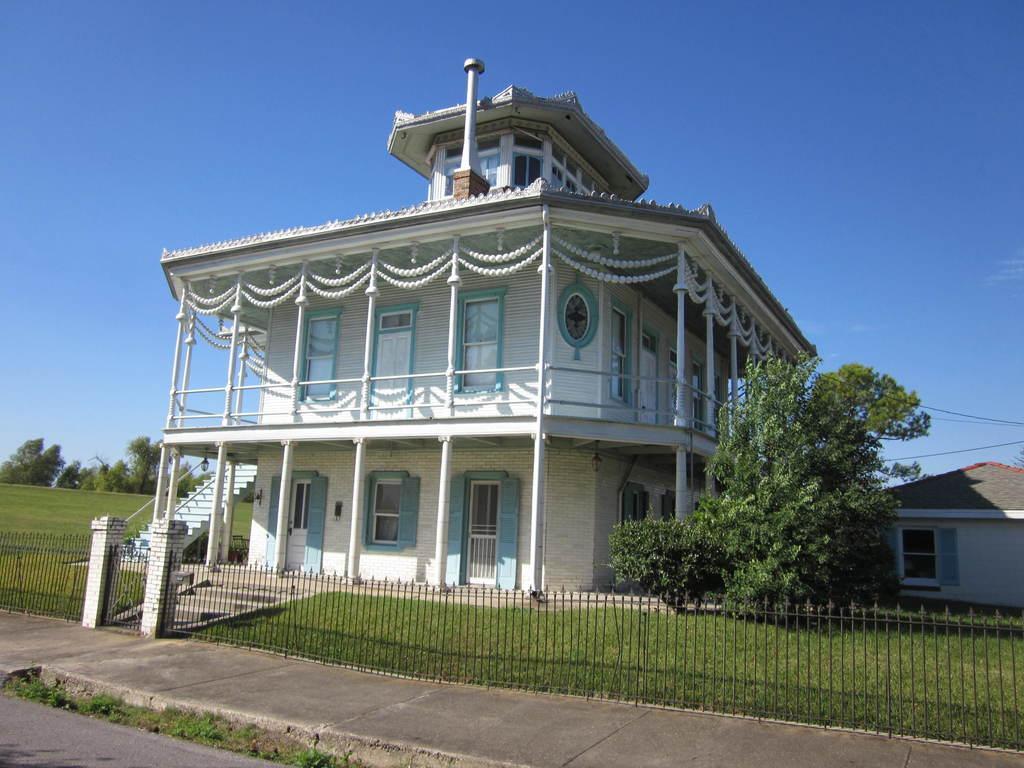Can you describe this image briefly? In this image, we can see building, house, walls, poles, railings, windows, doors, stairs, grass, trees and plants. At the bottom of the image, we can see fence, walkway, road, plants and pillars. Background we can see the sky and trees. 